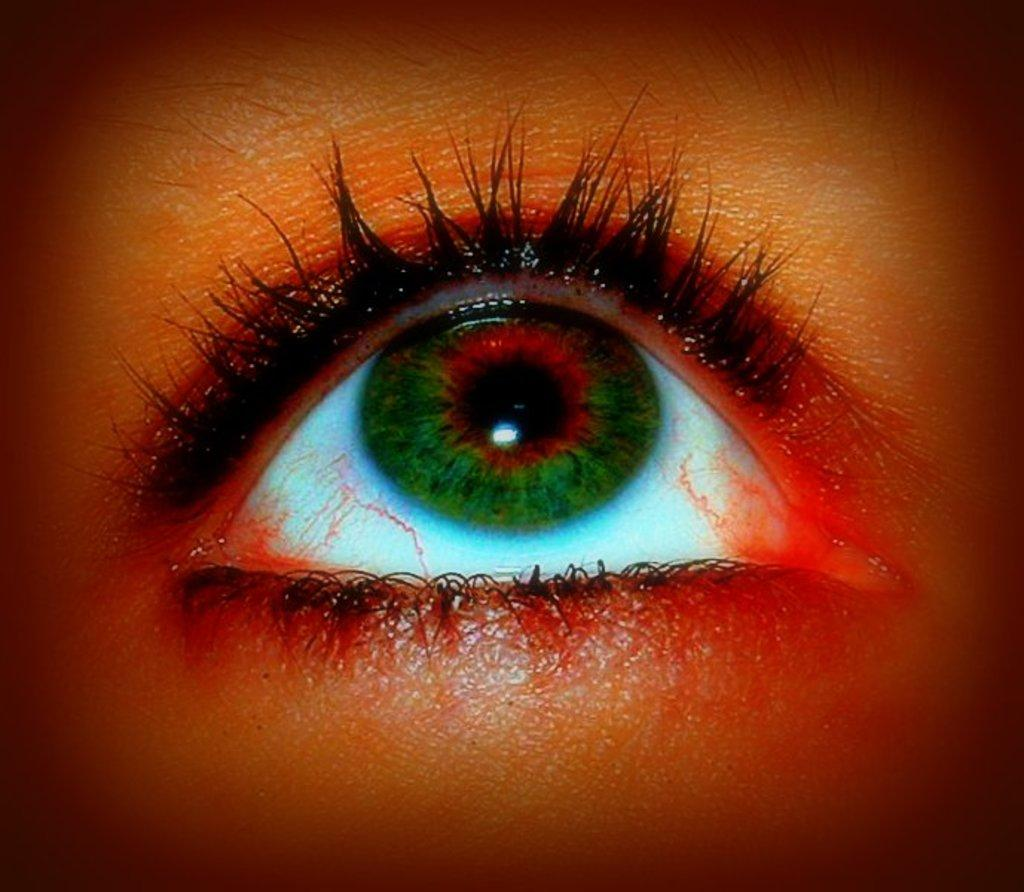What is the main subject of the image? The main subject of the image is an eye. What colors are present in the eye? The eye has a red color and a green color in the middle. What word is written on the art piece featuring the yam in the image? There is no art piece or yam present in the image; it only features an eye with red and green colors. 